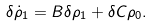Convert formula to latex. <formula><loc_0><loc_0><loc_500><loc_500>\delta \dot { \rho } _ { 1 } = B \delta \rho _ { 1 } + \delta C \rho _ { 0 } .</formula> 